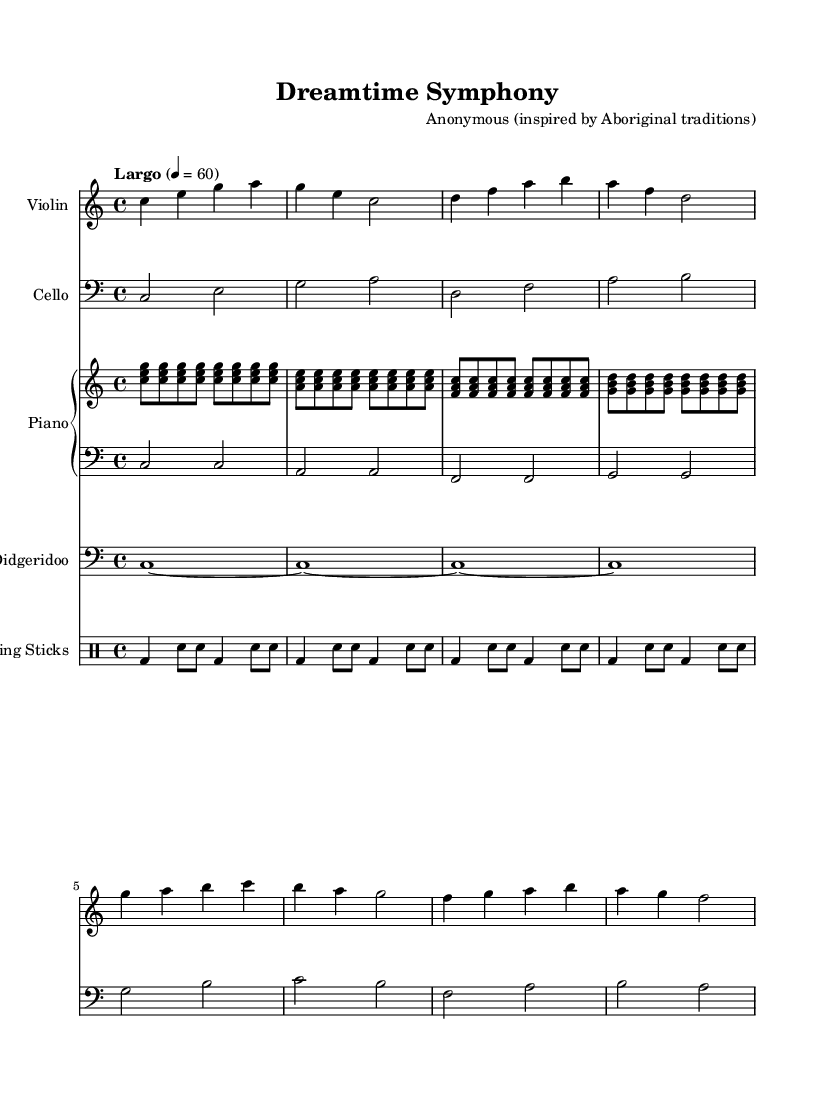What is the key signature of this music? The key signature is indicated in the global section, where it is stated as C major, which has no sharps or flats.
Answer: C major What is the time signature of the piece? The time signature is also found in the global section, listed as 4/4, which indicates four beats per measure.
Answer: 4/4 What is the tempo marking for this piece? The tempo marking is specified in the global section, stating "Largo" with a speed of 60 beats per minute.
Answer: Largo How many measures are present in the violin music? By counting the measures indicated in the violin staff, there are a total of eight measures in the violin music.
Answer: 8 Which instrument plays the didgeridoo music? The didgeridoo music is assigned to the corresponding staff labeled "Didgeridoo" in the score, clarifying which instrument is playing this part.
Answer: Didgeridoo What is the rhythmic pattern of the clapping sticks? The rhythmic pattern is outlined in the drummode section, which shows the placement of bass drums and snare notes that create a repeating rhythmic structure throughout the music.
Answer: bass and snare 